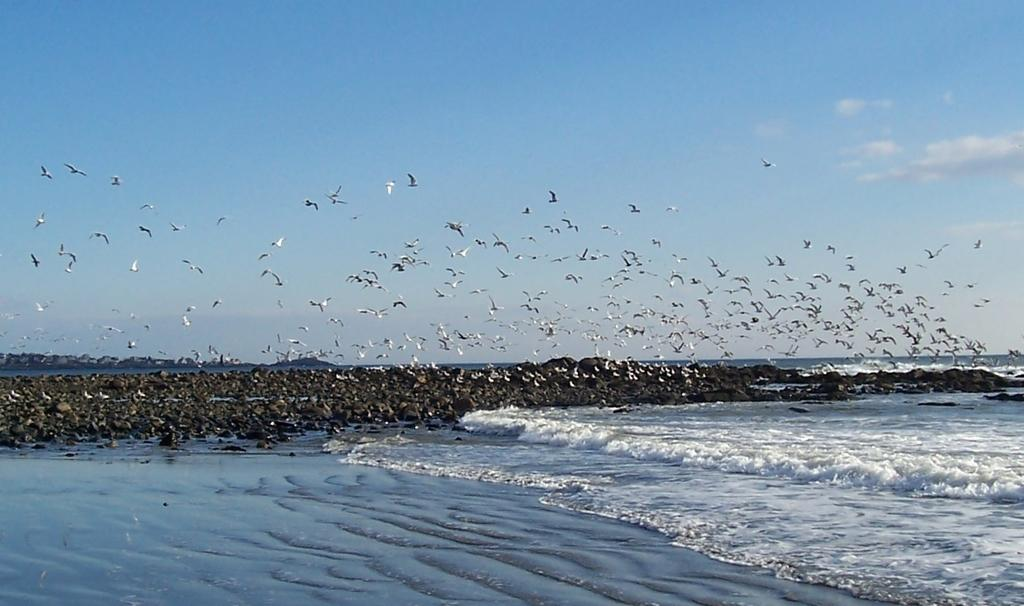What can be seen in the background of the image? The sky is visible in the background of the image. What is happening in the sky in the image? There are birds flying in the image. What else is visible in the image besides the sky and birds? There is water and rocks present in the image. What type of prose can be seen on the rocks in the image? There is no prose visible on the rocks in the image; they are natural formations. Can you identify any laborers working in the image? There are no laborers present in the image. 